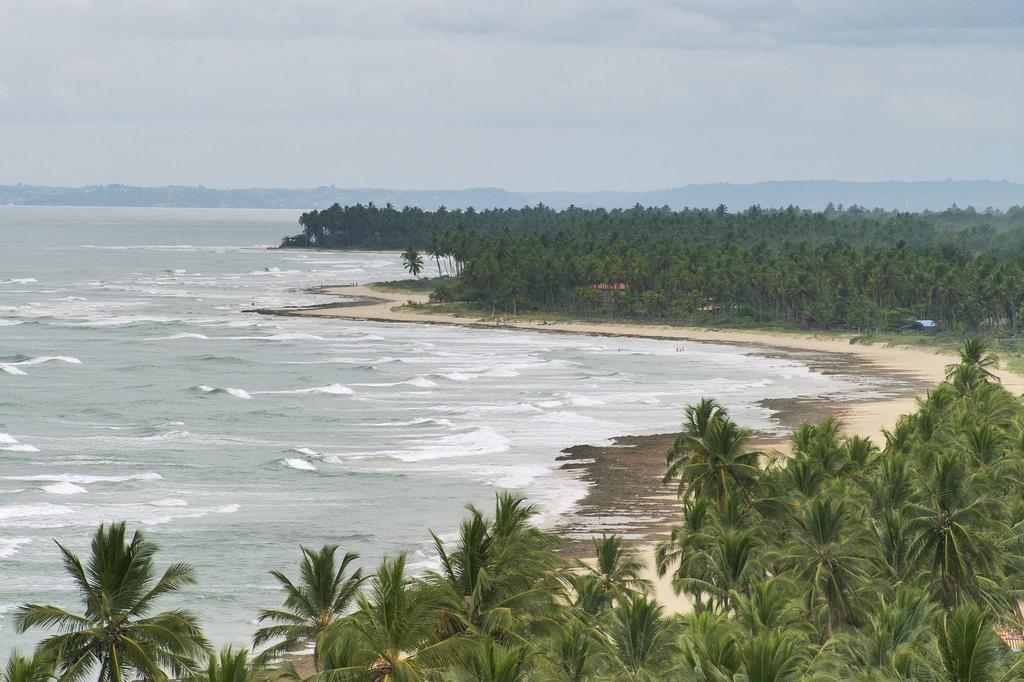What type of natural feature can be seen in the image? There is a sea in the image. What is located in front of the sea? There are tall trees in front of the sea. What type of news can be heard coming from the sea in the image? There is no indication of any news or sounds coming from the sea in the image. 